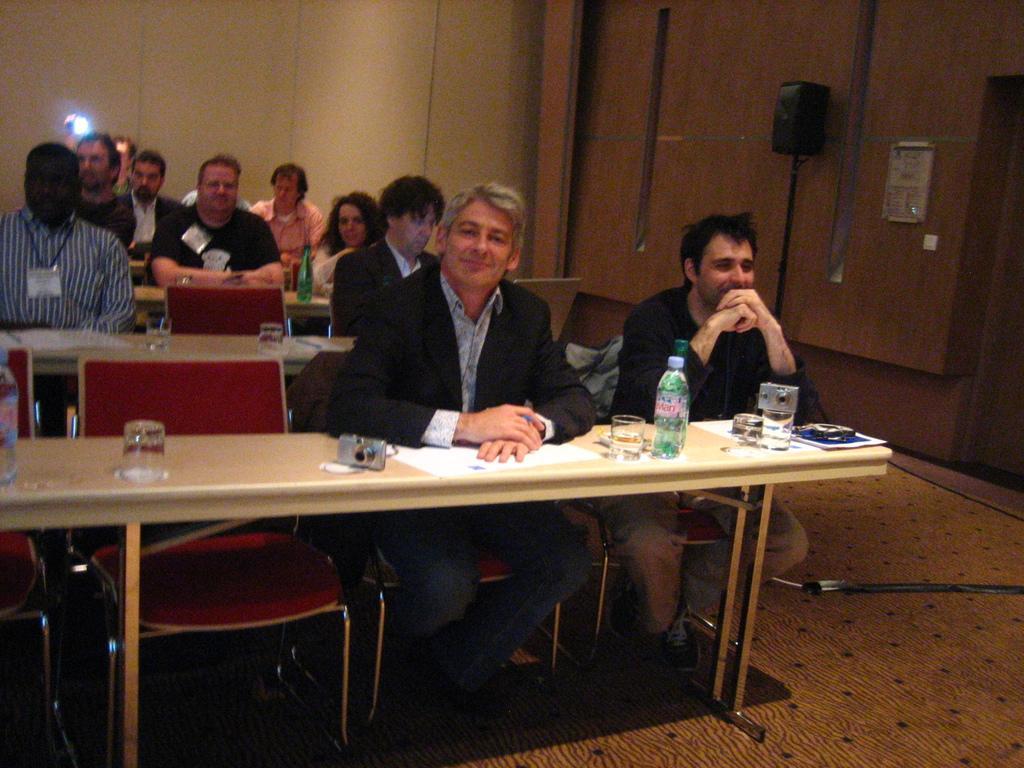Can you describe this image briefly? In this image i can see a group of people sitting on chairs in front of tables, On the tables i can see a camera, few glasses and few bottles. In the background i can see a wall and a speaker. 